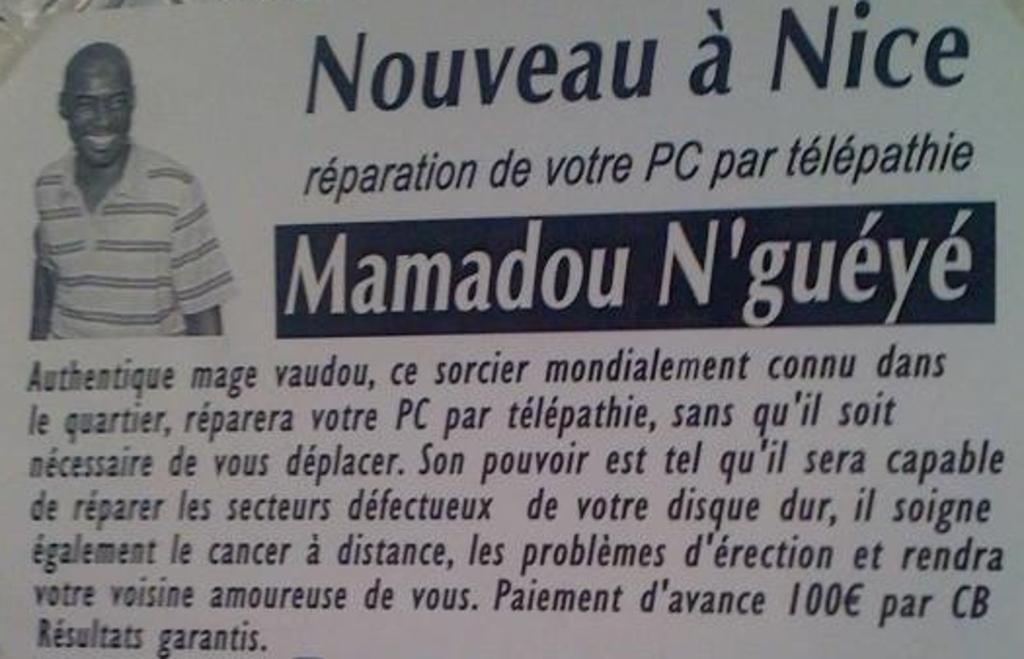Describe this image in one or two sentences. In this picture we can see a poster, on this poster we can see a man and text. 